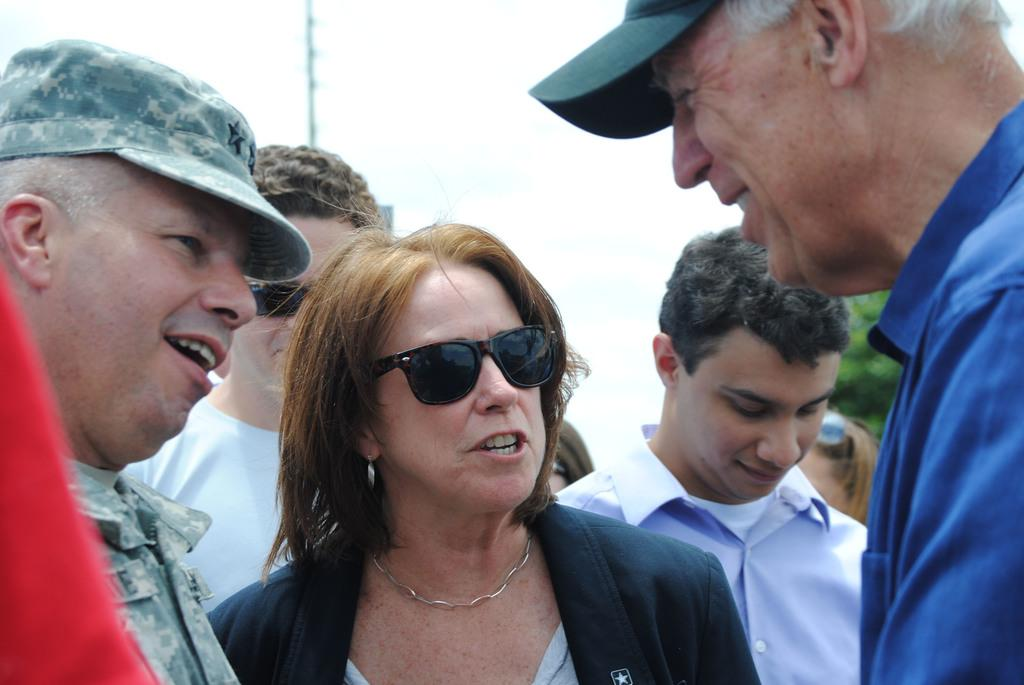How many people are in the group in the image? There is a group of people in the image, but the exact number is not specified. What accessories are some people wearing in the group? Some people in the group are wearing caps and some are wearing spectacles. What can be seen in the background of the image? There is a pole and a tree in the background of the image. What type of acoustics can be heard in the image? There is no information about any sounds or acoustics in the image, so it cannot be determined. Can you tell me how many oranges are on the tree in the image? There is no tree with oranges in the image; it only features a tree without any fruit. 